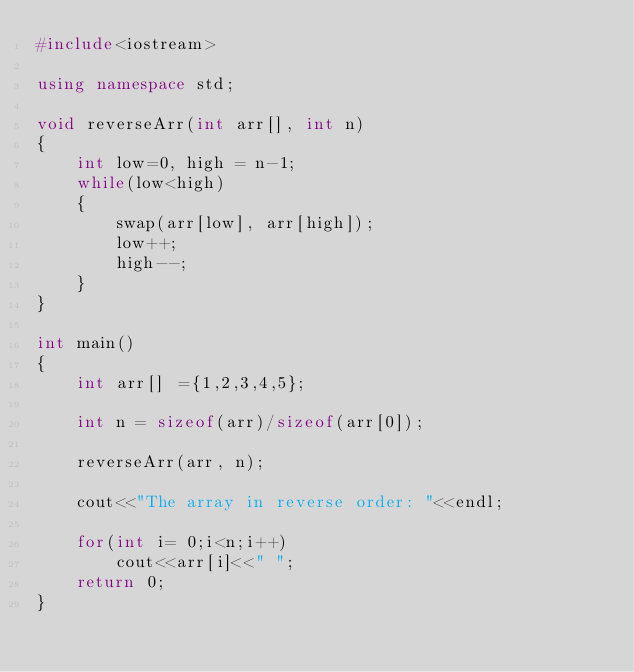<code> <loc_0><loc_0><loc_500><loc_500><_C++_>#include<iostream>

using namespace std;

void reverseArr(int arr[], int n)
{
    int low=0, high = n-1;
    while(low<high)
    {
        swap(arr[low], arr[high]);
        low++;
        high--;
    }
}

int main()
{
    int arr[] ={1,2,3,4,5};

    int n = sizeof(arr)/sizeof(arr[0]);

    reverseArr(arr, n);

    cout<<"The array in reverse order: "<<endl;

    for(int i= 0;i<n;i++)
        cout<<arr[i]<<" ";
    return 0;
}
</code> 